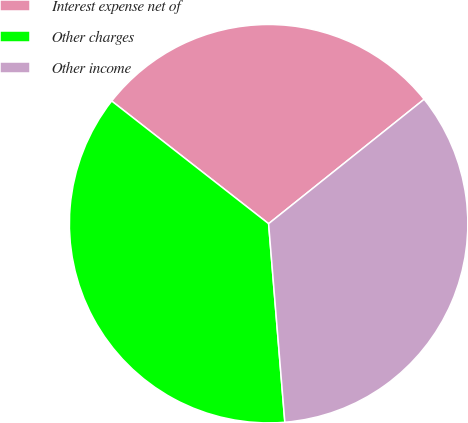Convert chart to OTSL. <chart><loc_0><loc_0><loc_500><loc_500><pie_chart><fcel>Interest expense net of<fcel>Other charges<fcel>Other income<nl><fcel>28.7%<fcel>36.86%<fcel>34.44%<nl></chart> 